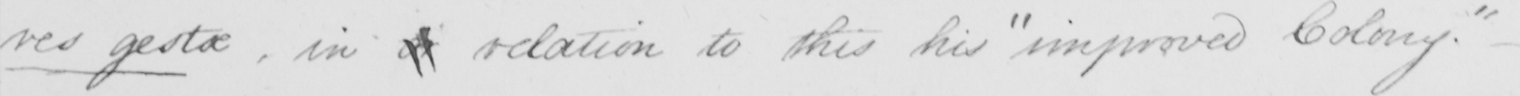Please provide the text content of this handwritten line. res gestae , in a relation to this his  " improved Colony . " 